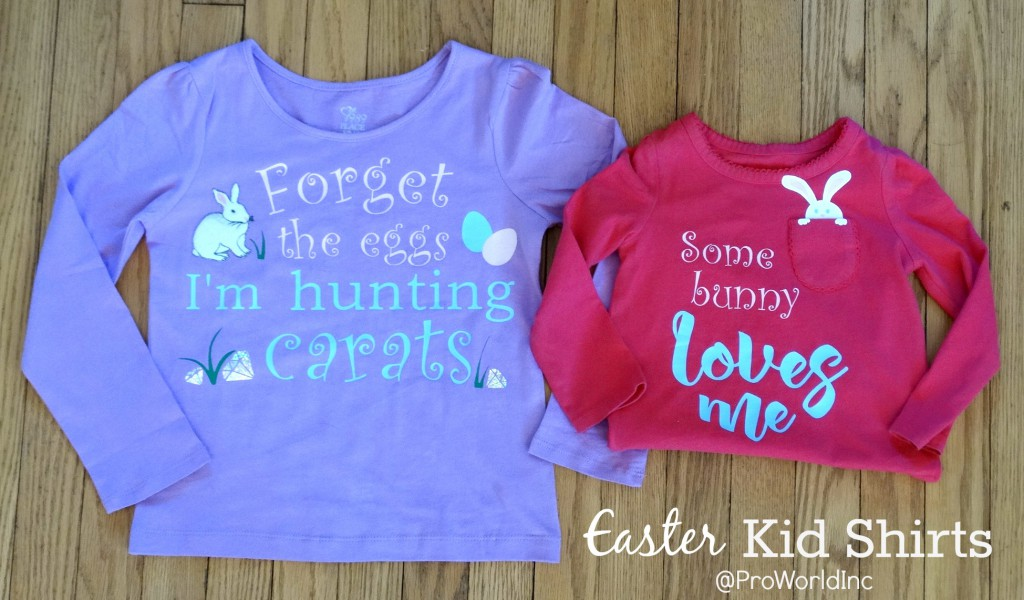What types of wildflowers are visible in the meadow, and do they vary in color? The image does not display a meadow or any wildflowers; instead, it shows two children's shirts with Easter-themed designs. One shirt is purple with the text 'Forget the eggs I'm hunting carrots' alongside a graphic of a bunny and carrots. The other shirt is red and reads 'Some bunny loves me' with a bunny graphic. Both incorporate playful fonts and Easter motifs. 